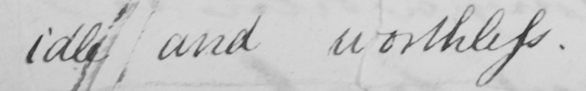What is written in this line of handwriting? idle and worthless. 